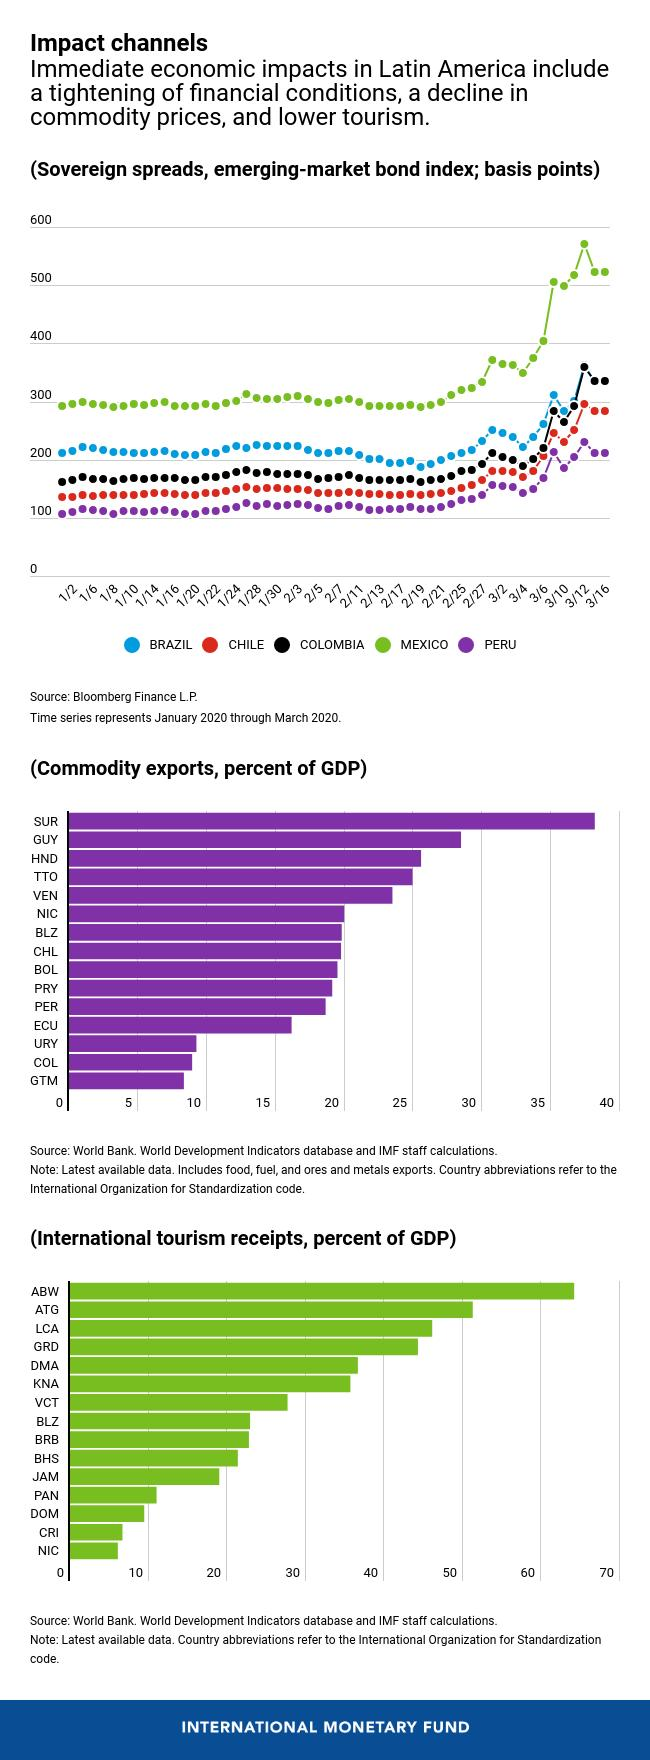List a handful of essential elements in this visual. The color code given to Colombia is yellow, red, purple, and black. Colombia crossed the 300 margin on March 12th. Mexico has the largest sovereign spread among countries in Latin America. China ranks third in commodity exports in terms of GDP, after the United States and Australia. Mexico crossed the 500 margin on March 10th of the month of March. 